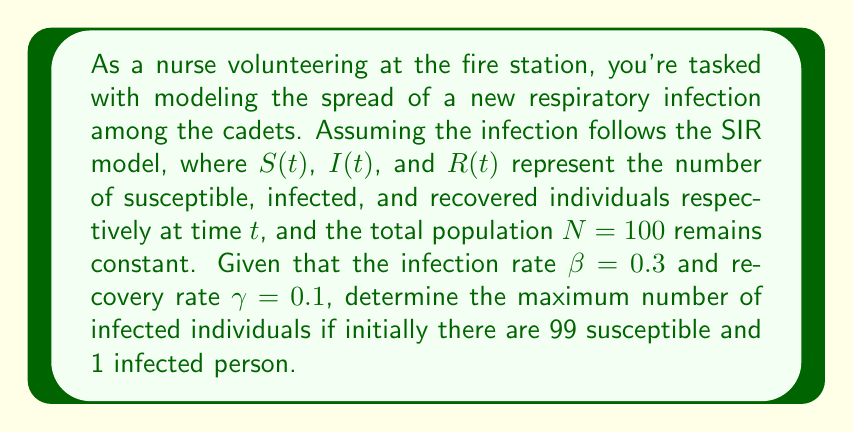Can you answer this question? Let's approach this step-by-step:

1) The SIR model is described by the following system of differential equations:

   $$\frac{dS}{dt} = -\beta SI/N$$
   $$\frac{dI}{dt} = \beta SI/N - \gamma I$$
   $$\frac{dR}{dt} = \gamma I$$

2) The maximum number of infected individuals occurs when $\frac{dI}{dt} = 0$. At this point:

   $$\beta SI/N - \gamma I = 0$$

3) Solving for S:

   $$\beta S/N = \gamma$$
   $$S = \gamma N / \beta = 0.1 * 100 / 0.3 = 33.33$$

4) Since S represents people, we round up to 34.

5) Given $N = S + I + R = 100$, and initially $R(0) = 0$, we can find the maximum I:

   $$I_{max} = 100 - 34 = 66$$

Therefore, the maximum number of infected individuals will be 66.
Answer: 66 